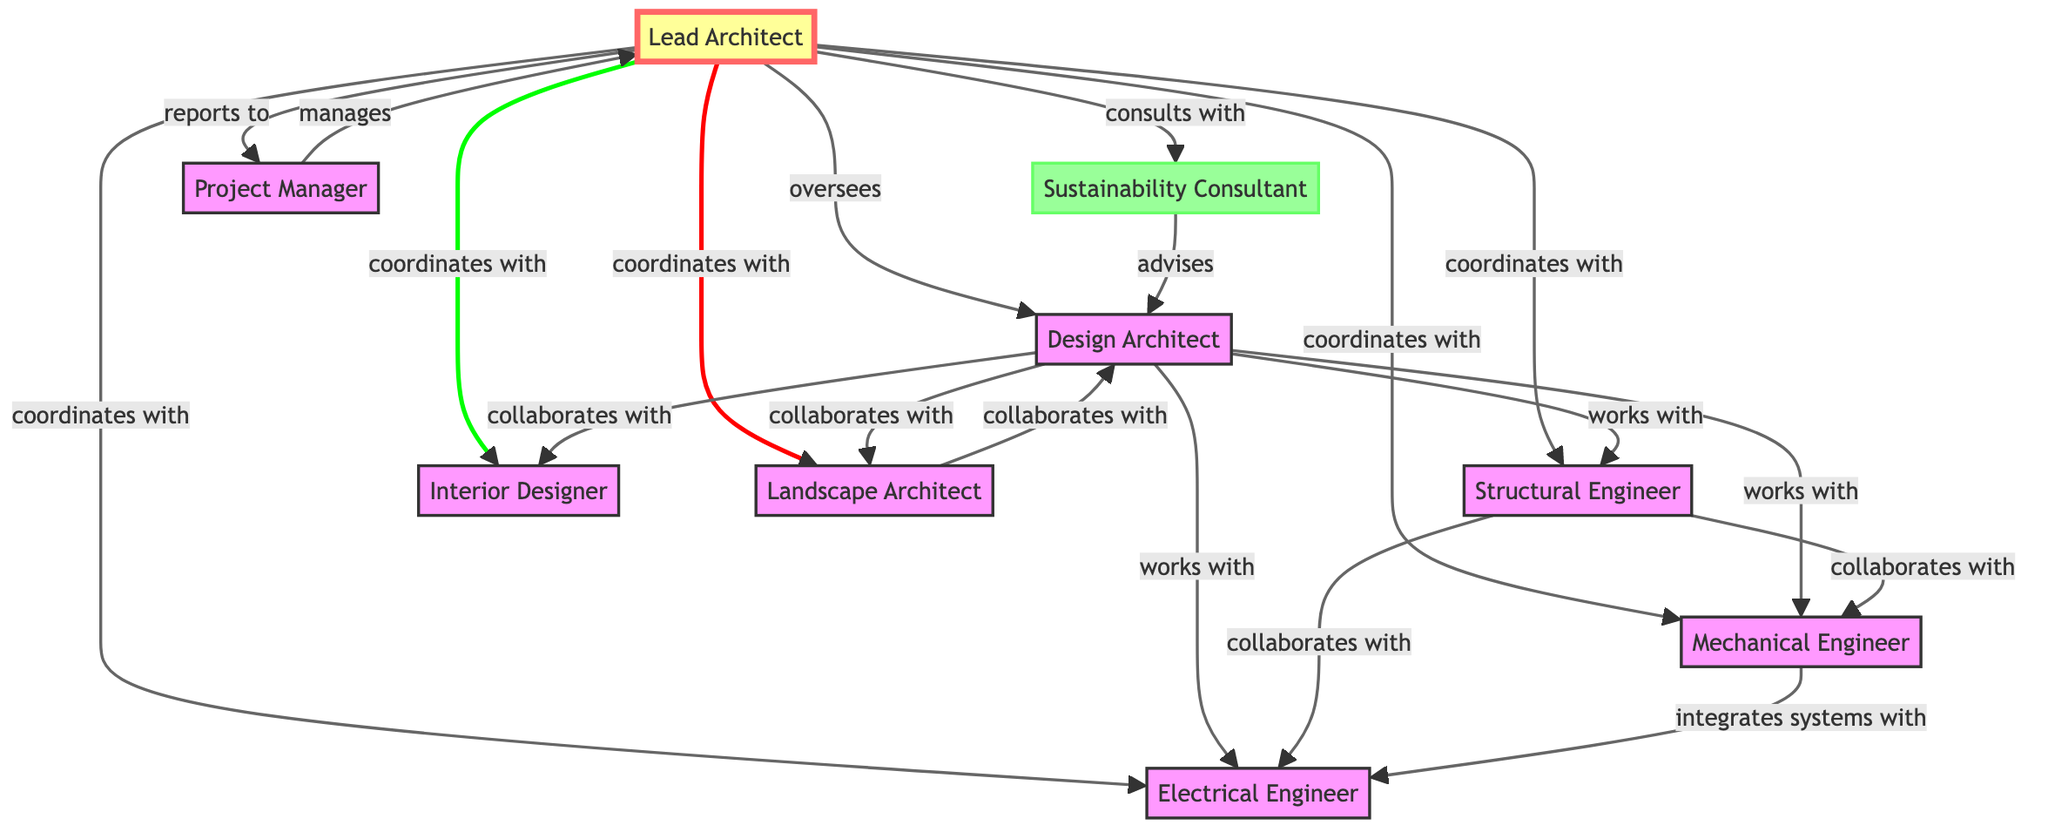What is the role of the Lead Architect? The Lead Architect oversees the entire project, making crucial decisions and ensuring alignment with client requirements. This can be deduced from the description attached to the Lead Architect node.
Answer: oversees the entire project How many nodes are in this directed graph? By counting the unique roles listed in the node data, we can determine there are 9 distinct positions represented as nodes in the graph.
Answer: 9 Which role reports to the Project Manager? Analyzing the edges, the arrow labeled "manages" that connects the Project Manager to the Lead Architect indicates that the Lead Architect reports to the Project Manager.
Answer: Lead Architect What type of relationship exists between the Design Architect and the Interior Designer? The edge labeled "collaborates with" shows that the Design Architect has a collaborative relationship with the Interior Designer. Observing the relevant nodes and their connecting edges allows us to identify the type of relationship.
Answer: collaborates with Who does the Sustainability Consultant advise? The edge labeled "advises" leads from the Sustainability Consultant to the Design Architect, indicating the specific guidance provided by the consultant to this role.
Answer: Design Architect How many roles does the Lead Architect coordinate with? By examining the edges that originate from the Lead Architect, we can count 5 roles (Structural Engineer, Mechanical Engineer, Electrical Engineer, Interior Designer, and Landscape Architect) that are coordinated with by the Lead Architect.
Answer: 5 Which two roles have a direct collaboration relation? The edges labeled "works with" between the Design Architect and the Structural Engineer demonstrate their collaboration. To identify such relationships, we can look for edges connecting two roles with this label.
Answer: works with What is the type of relationship between the Mechanical Engineer and the Electrical Engineer? The edge labeled "integrates systems with" indicates that the Mechanical Engineer has a relationship focused on system integration with the Electrical Engineer. This relationship can be analyzed by reviewing the edges connected between these two roles.
Answer: integrates systems with Which role collaborates with both the Design Architect and the Landscape Architect? The edge labeled "collaborates with" extending from the Design Architect to the Landscape Architect shows a collaborative bond. This relationship can be verified by examining the connecting edges from the relevant node.
Answer: collaborates with 